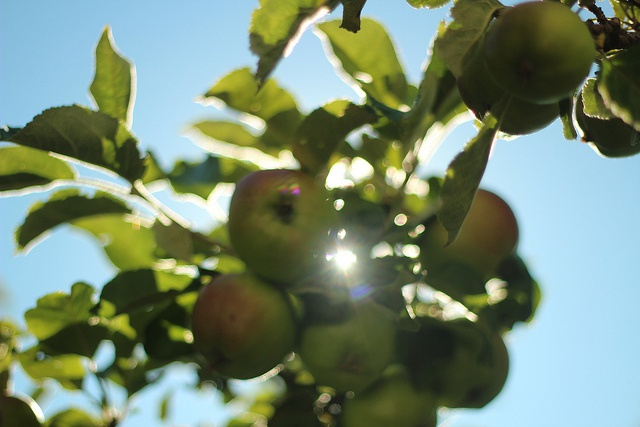Describe the objects in this image and their specific colors. I can see apple in lightblue, darkgreen, and gray tones, apple in lightblue, black, and darkgreen tones, apple in lightblue, black, and darkgreen tones, apple in lightblue, darkgreen, and gray tones, and apple in lightblue, black, darkgreen, and olive tones in this image. 